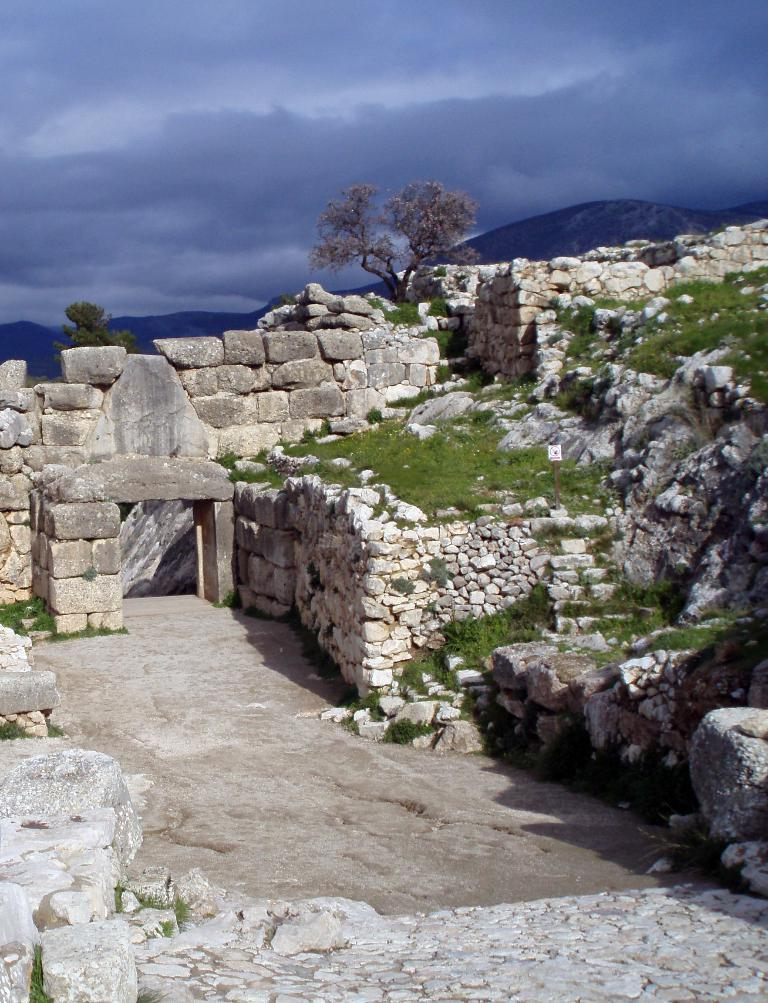What type of natural elements can be seen in the image? There are stones, grass, trees, and mountains visible in the image. What is the color of the sky in the background of the image? The sky is visible in the background of the image. Can you describe the terrain in the image? The terrain in the image includes grass, trees, and mountains. What type of letters can be seen on the farm in the image? There is no farm or letters present in the image; it features natural elements such as stones, grass, trees, and mountains. 